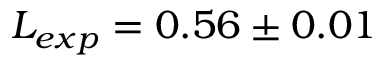<formula> <loc_0><loc_0><loc_500><loc_500>L _ { e x p } = 0 . 5 6 \pm 0 . 0 1</formula> 